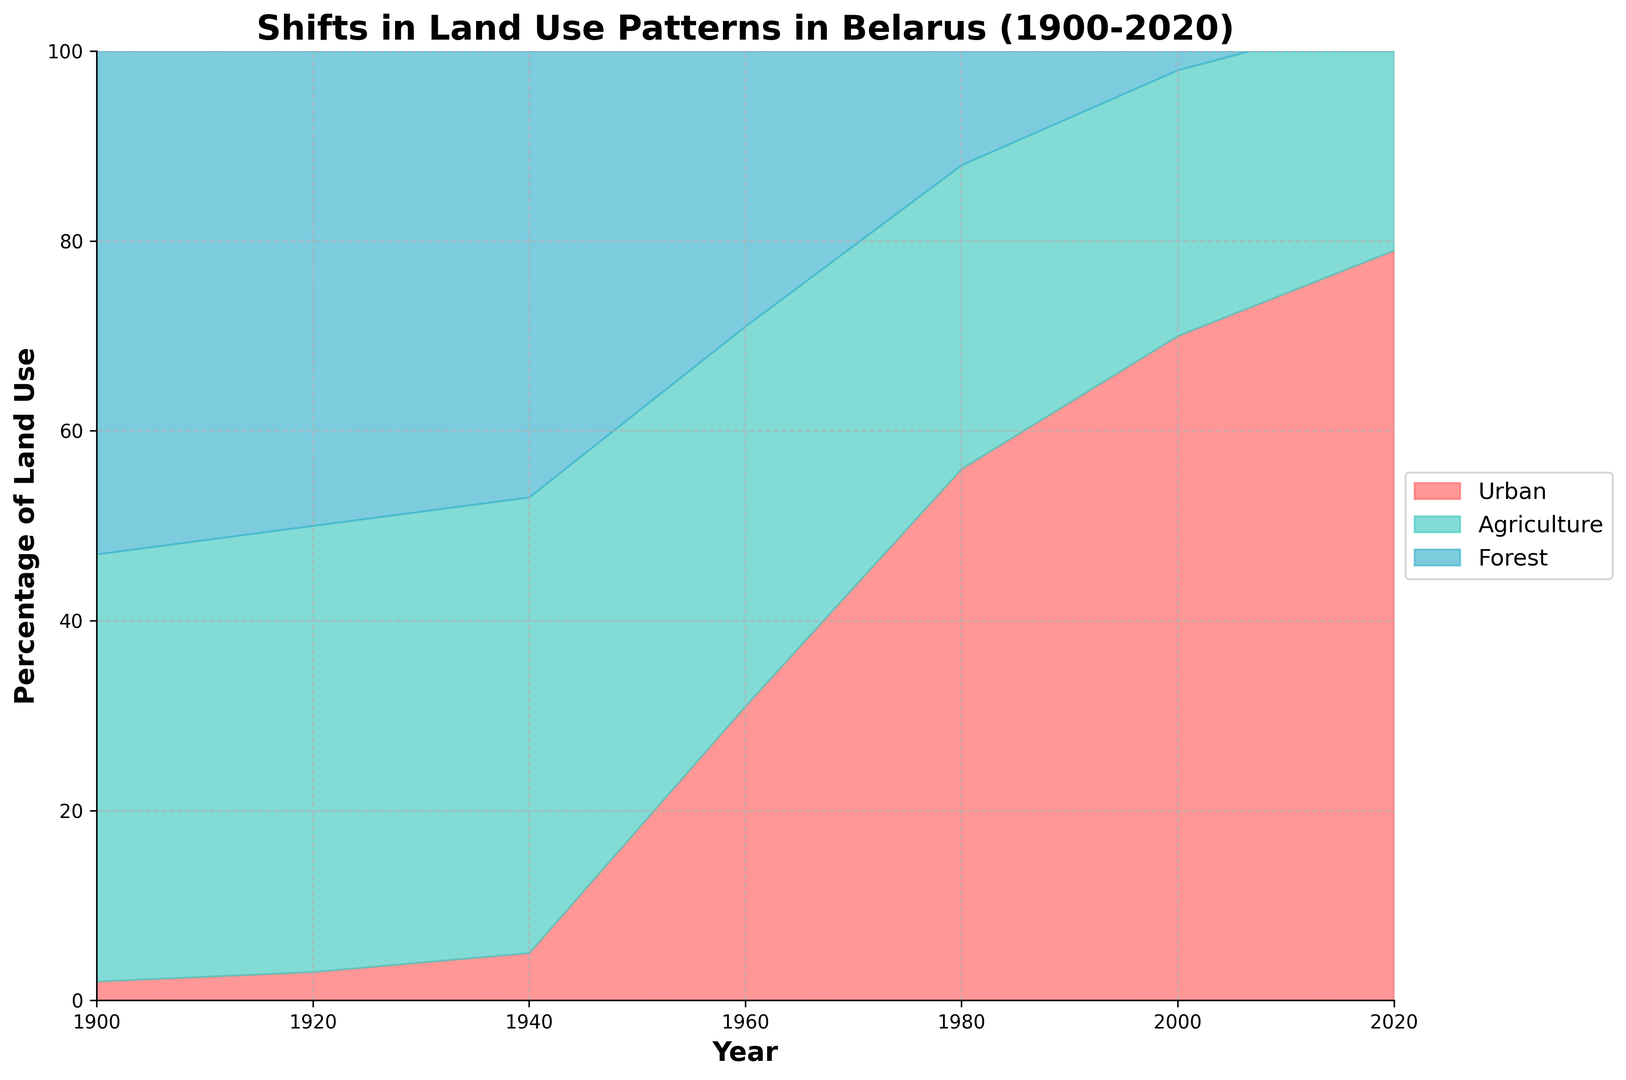What is the difference between the percentage of urban and agricultural land use in 2020? In 2020, the percentage of urban land use is 79%, and agricultural land use is 25%. The difference is 79% - 25%
Answer: 54% Which year had the highest percentage of urban land use? By observing the red section of the chart, 2020 had the highest percentage of urban land use at 79%.
Answer: 2020 How has forest cover changed from 1900 to 2020? In 1900, forest cover was at 33%, and in 2020 it increased to 39%. The difference is 39% - 33% = 6%
Answer: Increased by 6% What is the combined percentage of urban and agricultural land in 1980? In 1980, urban land use was 56%, and agricultural land use was 32%. The combined percentage is 56% + 32%
Answer: 88% Which land use type had the smallest change in percentage from 1900 to 2020? From 1900 to 2020, urban land increased by 77%, agricultural land decreased by 20%, and forest cover increased by 6%. The smallest change is in forest cover.
Answer: Forest In which decade did the most significant increase in urban land use occur? By observing the slope of the red section, the most significant increase in urban land use occurred between 1940 and 1960.
Answer: 1940-1960 Is the percentage of forest cover greater in 2020 or 1940? The blue section in 2020 is at 39%, and in 1940 it is at 29%. Thus, forest cover is greater in 2020.
Answer: 2020 What is the visual color representation of agriculture in the plot? Agriculture is represented by the green color section in the chart, located between urban and forest cover.
Answer: Green How has agricultural land use trended from 1900 to 2020? Agricultural land use increased initially from 45% to 48% by 1940 but then continuously declined to 25% by 2020.
Answer: Decreased overall What is the total percentage of land not covered by forest in 2000? In 2000, the forest cover was 35%. Hence, the land not covered by forest is 100% - 35%.
Answer: 65% 